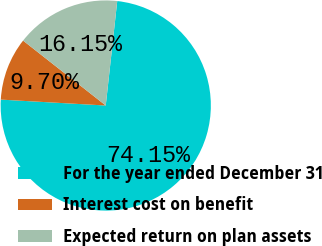Convert chart. <chart><loc_0><loc_0><loc_500><loc_500><pie_chart><fcel>For the year ended December 31<fcel>Interest cost on benefit<fcel>Expected return on plan assets<nl><fcel>74.15%<fcel>9.7%<fcel>16.15%<nl></chart> 